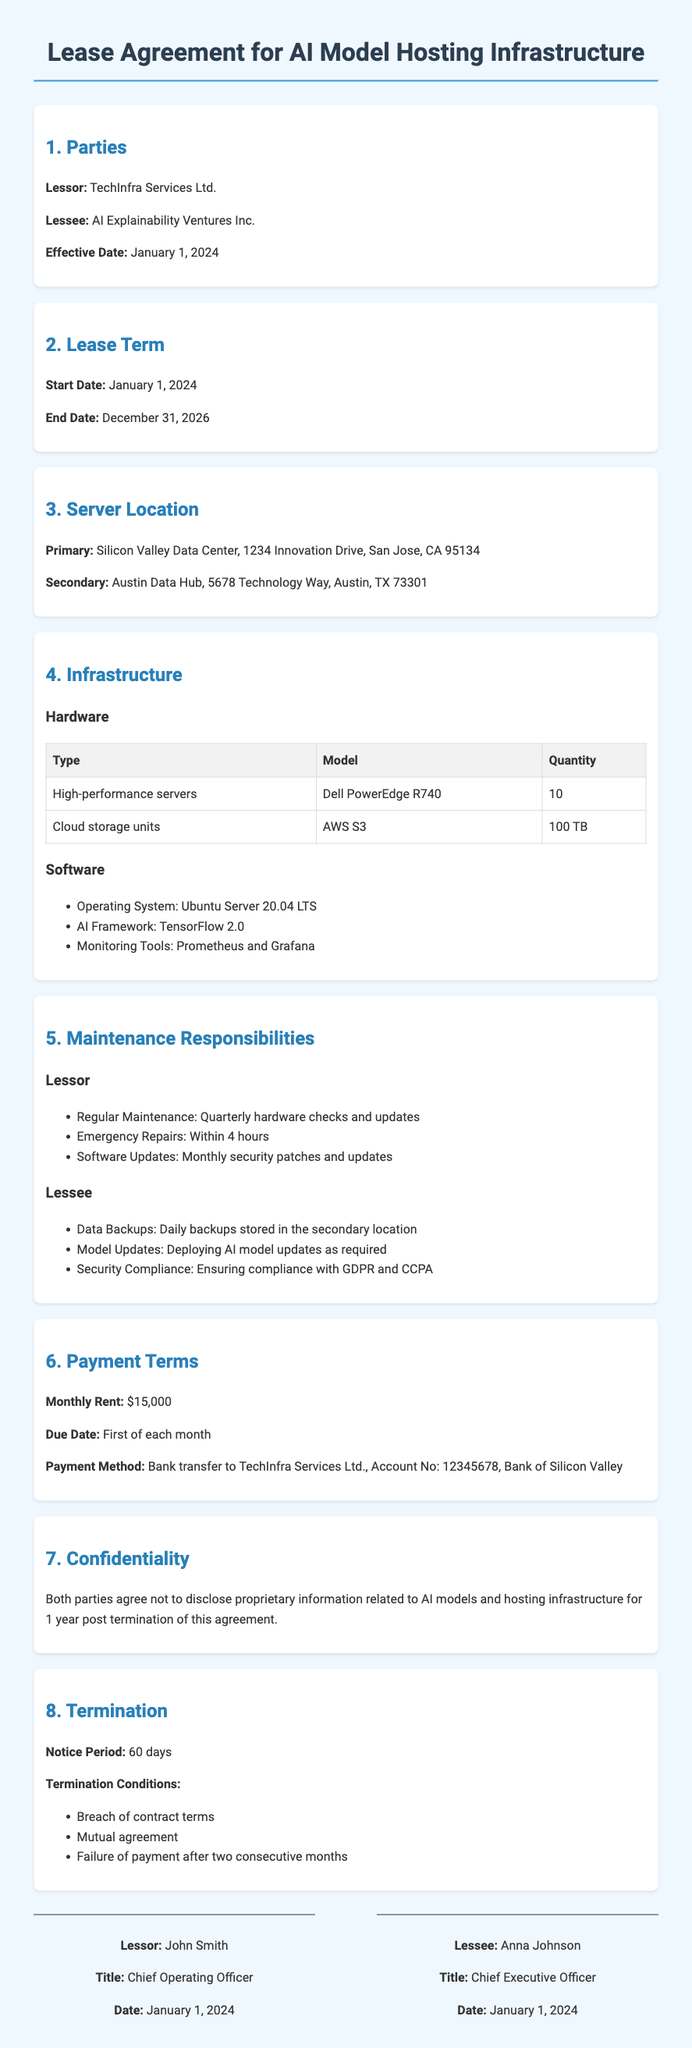What is the name of the lessor? The lessor is listed in the document as the entity responsible for the lease agreement, which is TechInfra Services Ltd.
Answer: TechInfra Services Ltd What is the start date of the lease term? The start date is explicitly mentioned in the section regarding the lease term, which is January 1, 2024.
Answer: January 1, 2024 What is the end date of the lease term? The end date can be found in the lease term section, which states that it ends on December 31, 2026.
Answer: December 31, 2026 How many high-performance servers are included in the lease? The quantity of high-performance servers is provided in the infrastructure section, which states there are 10.
Answer: 10 What is the primary server location? The document specifies the primary location for the servers as the Silicon Valley Data Center.
Answer: Silicon Valley Data Center What is the monthly rent amount? The payment terms section provides this information, which states the monthly rent is $15,000.
Answer: $15,000 What is the notice period for termination? The termination section of the document specifies the notice period required, which is 60 days.
Answer: 60 days Which party is responsible for regular maintenance? The maintenance responsibilities section details the obligations, stating that the lessor is responsible for regular maintenance.
Answer: Lessor What is the required timeframe for emergency repairs? The document specifies the timeframe for emergency repairs in the maintenance responsibilities section, stating they must be completed within 4 hours.
Answer: 4 hours 